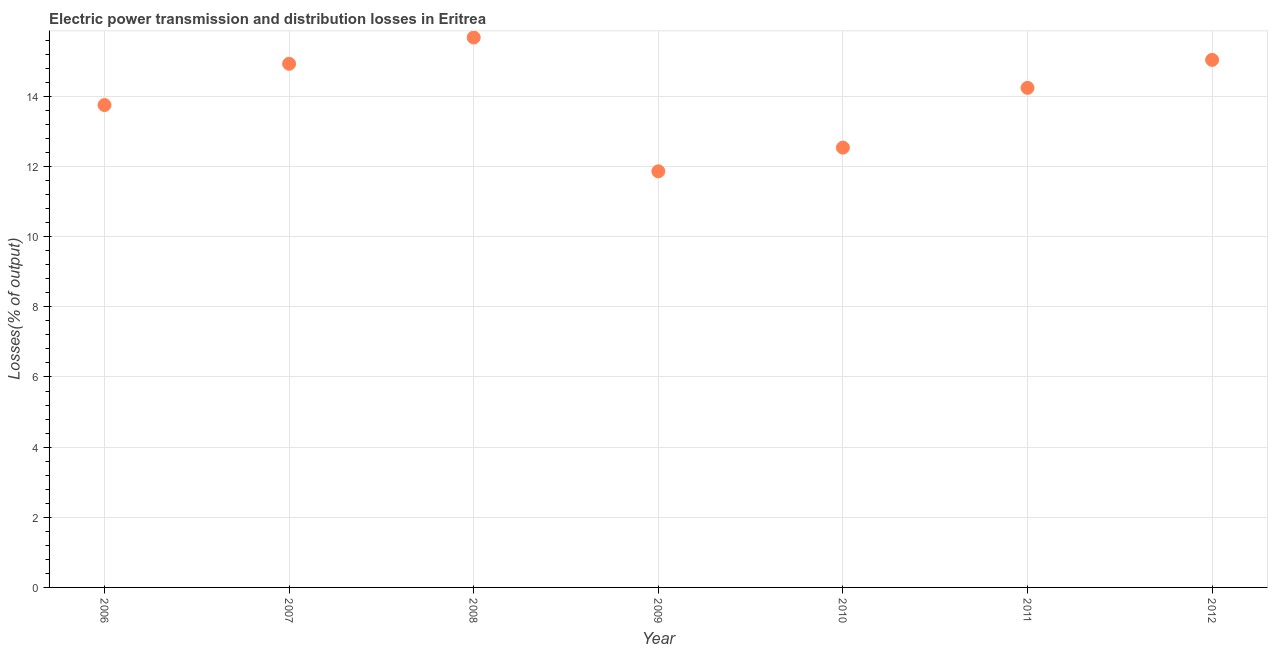What is the electric power transmission and distribution losses in 2010?
Provide a succinct answer. 12.54. Across all years, what is the maximum electric power transmission and distribution losses?
Your answer should be very brief. 15.68. Across all years, what is the minimum electric power transmission and distribution losses?
Your answer should be very brief. 11.86. In which year was the electric power transmission and distribution losses maximum?
Offer a terse response. 2008. What is the sum of the electric power transmission and distribution losses?
Offer a very short reply. 98.05. What is the difference between the electric power transmission and distribution losses in 2009 and 2011?
Offer a very short reply. -2.38. What is the average electric power transmission and distribution losses per year?
Make the answer very short. 14.01. What is the median electric power transmission and distribution losses?
Provide a succinct answer. 14.24. What is the ratio of the electric power transmission and distribution losses in 2007 to that in 2010?
Your answer should be very brief. 1.19. Is the electric power transmission and distribution losses in 2006 less than that in 2011?
Provide a short and direct response. Yes. Is the difference between the electric power transmission and distribution losses in 2008 and 2010 greater than the difference between any two years?
Your answer should be very brief. No. What is the difference between the highest and the second highest electric power transmission and distribution losses?
Keep it short and to the point. 0.64. Is the sum of the electric power transmission and distribution losses in 2009 and 2010 greater than the maximum electric power transmission and distribution losses across all years?
Provide a short and direct response. Yes. What is the difference between the highest and the lowest electric power transmission and distribution losses?
Offer a very short reply. 3.82. In how many years, is the electric power transmission and distribution losses greater than the average electric power transmission and distribution losses taken over all years?
Your answer should be very brief. 4. How many years are there in the graph?
Make the answer very short. 7. Are the values on the major ticks of Y-axis written in scientific E-notation?
Offer a terse response. No. Does the graph contain grids?
Your answer should be compact. Yes. What is the title of the graph?
Your response must be concise. Electric power transmission and distribution losses in Eritrea. What is the label or title of the X-axis?
Keep it short and to the point. Year. What is the label or title of the Y-axis?
Your answer should be very brief. Losses(% of output). What is the Losses(% of output) in 2006?
Keep it short and to the point. 13.75. What is the Losses(% of output) in 2007?
Your answer should be compact. 14.93. What is the Losses(% of output) in 2008?
Ensure brevity in your answer.  15.68. What is the Losses(% of output) in 2009?
Offer a very short reply. 11.86. What is the Losses(% of output) in 2010?
Offer a terse response. 12.54. What is the Losses(% of output) in 2011?
Give a very brief answer. 14.24. What is the Losses(% of output) in 2012?
Your response must be concise. 15.04. What is the difference between the Losses(% of output) in 2006 and 2007?
Make the answer very short. -1.18. What is the difference between the Losses(% of output) in 2006 and 2008?
Offer a very short reply. -1.92. What is the difference between the Losses(% of output) in 2006 and 2009?
Your response must be concise. 1.89. What is the difference between the Losses(% of output) in 2006 and 2010?
Offer a terse response. 1.21. What is the difference between the Losses(% of output) in 2006 and 2011?
Ensure brevity in your answer.  -0.49. What is the difference between the Losses(% of output) in 2006 and 2012?
Your answer should be very brief. -1.29. What is the difference between the Losses(% of output) in 2007 and 2008?
Offer a terse response. -0.75. What is the difference between the Losses(% of output) in 2007 and 2009?
Your answer should be very brief. 3.07. What is the difference between the Losses(% of output) in 2007 and 2010?
Give a very brief answer. 2.39. What is the difference between the Losses(% of output) in 2007 and 2011?
Make the answer very short. 0.69. What is the difference between the Losses(% of output) in 2007 and 2012?
Provide a succinct answer. -0.11. What is the difference between the Losses(% of output) in 2008 and 2009?
Offer a very short reply. 3.82. What is the difference between the Losses(% of output) in 2008 and 2010?
Make the answer very short. 3.14. What is the difference between the Losses(% of output) in 2008 and 2011?
Your response must be concise. 1.44. What is the difference between the Losses(% of output) in 2008 and 2012?
Make the answer very short. 0.64. What is the difference between the Losses(% of output) in 2009 and 2010?
Your answer should be very brief. -0.68. What is the difference between the Losses(% of output) in 2009 and 2011?
Your answer should be compact. -2.38. What is the difference between the Losses(% of output) in 2009 and 2012?
Provide a succinct answer. -3.18. What is the difference between the Losses(% of output) in 2010 and 2011?
Offer a terse response. -1.7. What is the difference between the Losses(% of output) in 2010 and 2012?
Provide a succinct answer. -2.5. What is the difference between the Losses(% of output) in 2011 and 2012?
Give a very brief answer. -0.8. What is the ratio of the Losses(% of output) in 2006 to that in 2007?
Keep it short and to the point. 0.92. What is the ratio of the Losses(% of output) in 2006 to that in 2008?
Your answer should be compact. 0.88. What is the ratio of the Losses(% of output) in 2006 to that in 2009?
Make the answer very short. 1.16. What is the ratio of the Losses(% of output) in 2006 to that in 2010?
Keep it short and to the point. 1.1. What is the ratio of the Losses(% of output) in 2006 to that in 2012?
Your answer should be very brief. 0.91. What is the ratio of the Losses(% of output) in 2007 to that in 2009?
Ensure brevity in your answer.  1.26. What is the ratio of the Losses(% of output) in 2007 to that in 2010?
Offer a very short reply. 1.19. What is the ratio of the Losses(% of output) in 2007 to that in 2011?
Your answer should be compact. 1.05. What is the ratio of the Losses(% of output) in 2008 to that in 2009?
Provide a succinct answer. 1.32. What is the ratio of the Losses(% of output) in 2008 to that in 2011?
Provide a succinct answer. 1.1. What is the ratio of the Losses(% of output) in 2008 to that in 2012?
Keep it short and to the point. 1.04. What is the ratio of the Losses(% of output) in 2009 to that in 2010?
Offer a terse response. 0.95. What is the ratio of the Losses(% of output) in 2009 to that in 2011?
Ensure brevity in your answer.  0.83. What is the ratio of the Losses(% of output) in 2009 to that in 2012?
Offer a very short reply. 0.79. What is the ratio of the Losses(% of output) in 2010 to that in 2012?
Provide a succinct answer. 0.83. What is the ratio of the Losses(% of output) in 2011 to that in 2012?
Offer a very short reply. 0.95. 